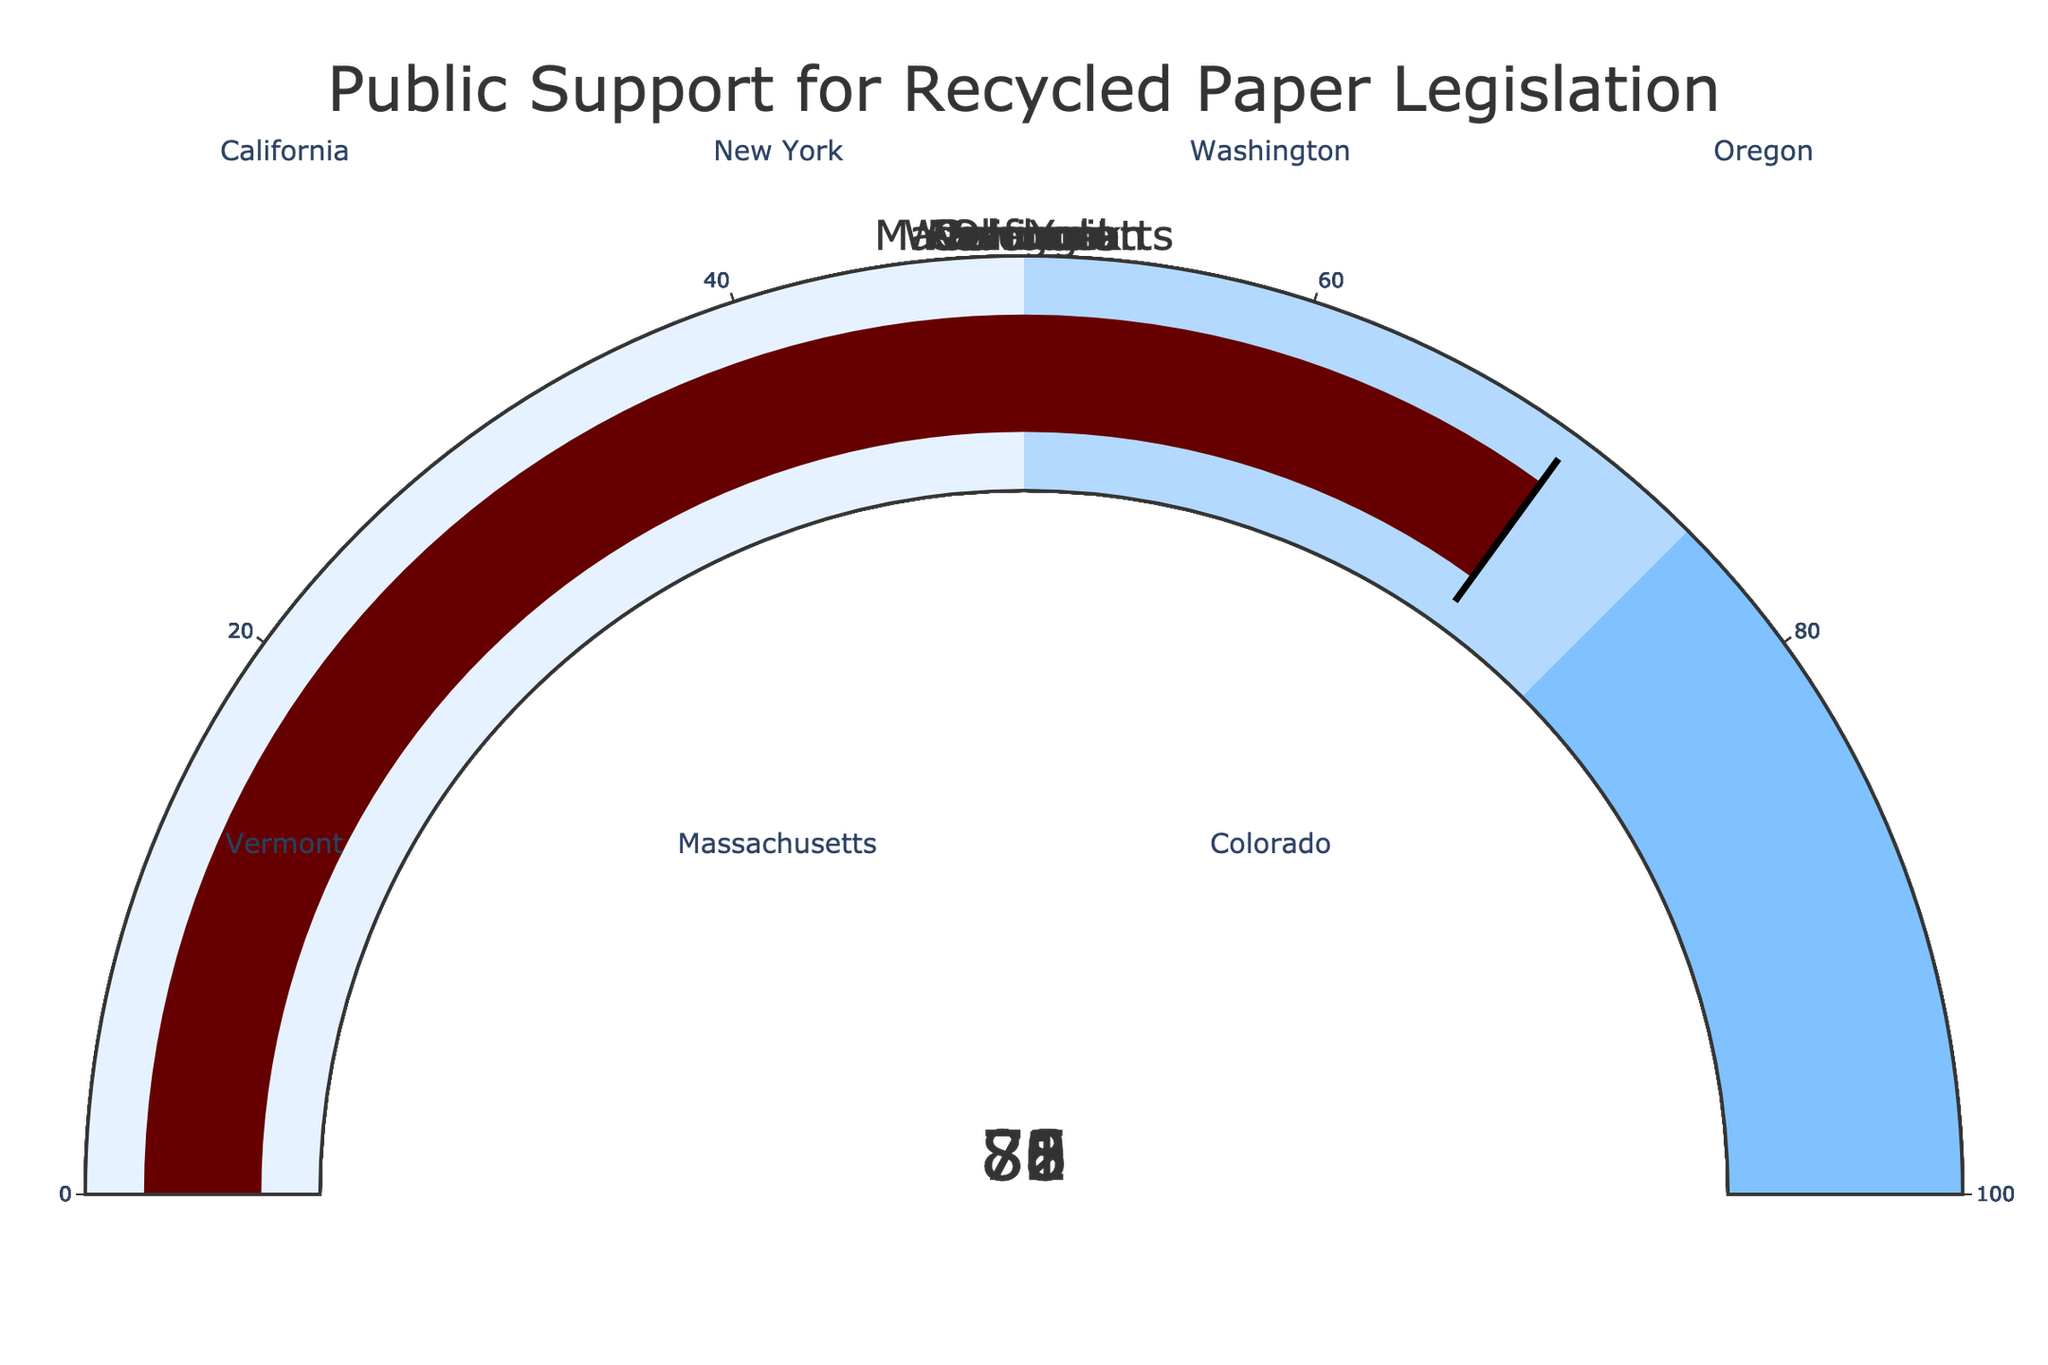What's the public support percentage for recycled paper legislation in California? Look for the gauge chart labeled "California" and note the percentage value displayed at the center of the gauge.
Answer: 78% Which state has the highest public support for recycled paper legislation? Compare all the percentage values on the gauge charts and identify the state with the highest value.
Answer: Vermont How much higher is the public support percentage in Oregon compared to Colorado? Identify the percentages for Oregon (83) and Colorado (70), then subtract the smaller number from the larger number: 83 - 70 = 13.
Answer: 13 What's the average public support percentage across all listed states? Sum the support percentages for all the states and divide by the number of states: (78 + 72 + 81 + 83 + 85 + 76 + 70) / 7 = 535 / 7 ≈ 76.43.
Answer: 76.43 Which states have a public support percentage greater than 80%? Identify and list the states with percentages above 80%: Washington (81), Oregon (83), Vermont (85).
Answer: Washington, Oregon, Vermont What's the range of the public support percentages across all states? Determine the highest and lowest percentages, then subtract the lowest from the highest: 85 (highest) - 70 (lowest) = 15.
Answer: 15 How does the public support in Massachusetts compare to the overall average support percentage? First, calculate the overall average (76.43 as calculated earlier). Then, compare the Massachusetts percentage (76) to the average: 76 is slightly below 76.43.
Answer: Below Which state has the lowest public support percentage for recycled paper legislation? Compare all the percentage values on the gauge charts and identify the state with the lowest value.
Answer: Colorado How many states have a public support percentage below 75%? Identify and count the states with percentages below 75: New York (72), Colorado (70).
Answer: 2 